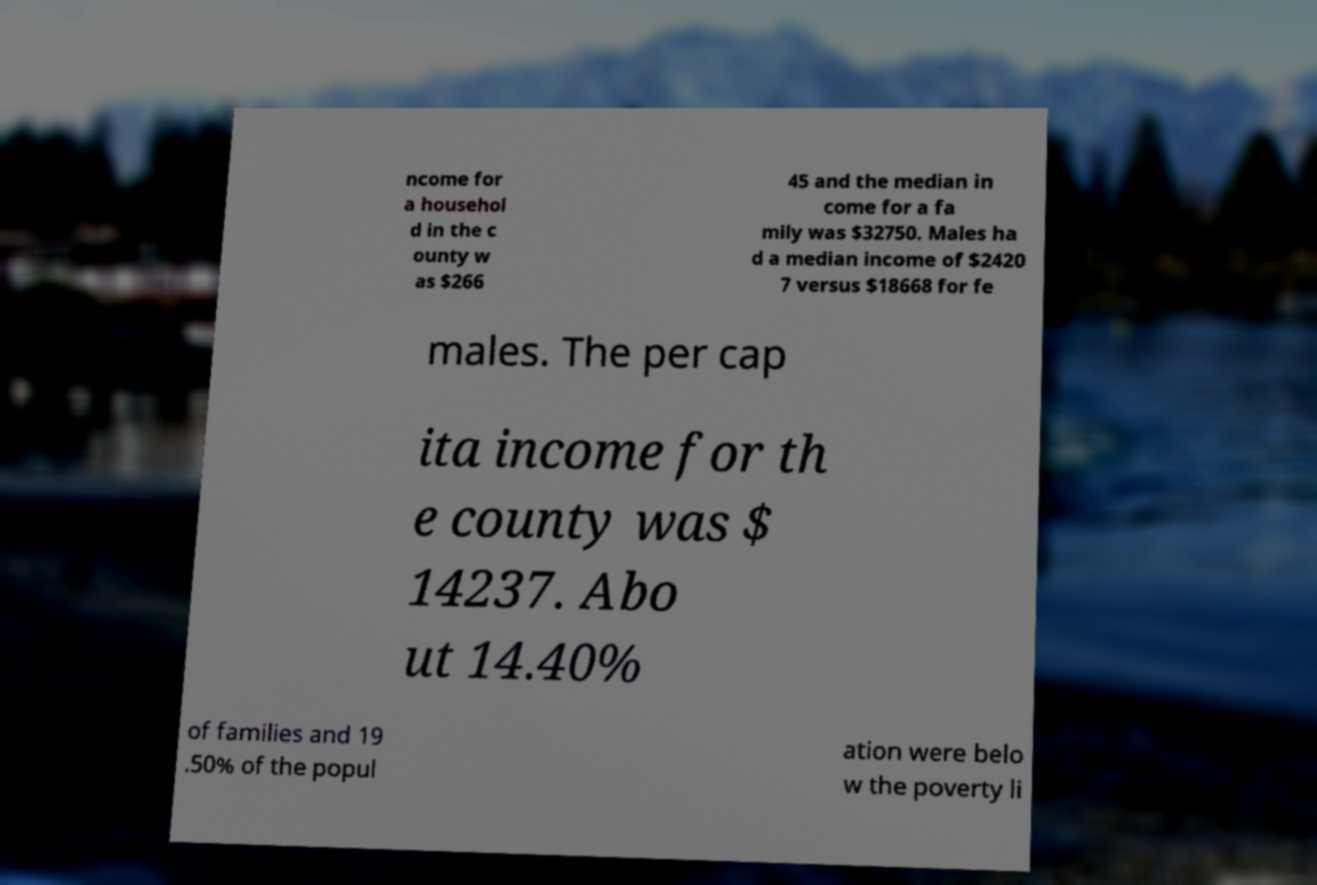Could you assist in decoding the text presented in this image and type it out clearly? ncome for a househol d in the c ounty w as $266 45 and the median in come for a fa mily was $32750. Males ha d a median income of $2420 7 versus $18668 for fe males. The per cap ita income for th e county was $ 14237. Abo ut 14.40% of families and 19 .50% of the popul ation were belo w the poverty li 